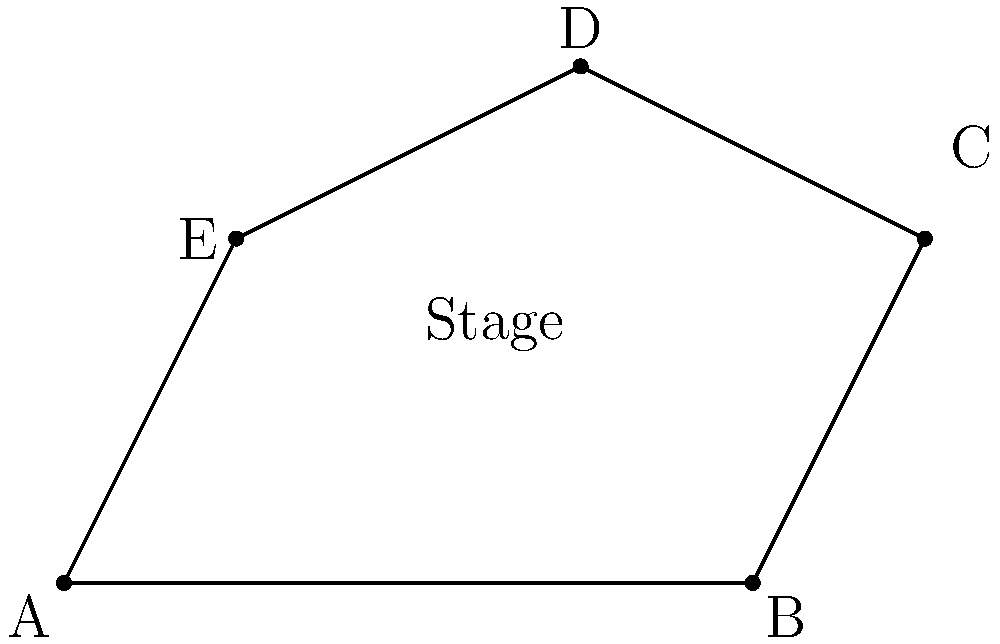Hey there, joke-slinger! You've been asked to perform on this weirdly shaped stage that looks like it was designed by a drunk geometry teacher. The stage's corners are at points A(0,0), B(8,0), C(10,4), D(6,6), and E(2,4). What's the area of this comedic playground? And remember, the bigger the stage, the more room for your ego! Alright, let's break this down like we're dissecting a particularly unfunny joke:

1) We can split this irregular shape into three triangles: ABC, ACD, and ADE.

2) For each triangle, we'll use the formula: 
   Area = $\frac{1}{2}|x_1(y_2 - y_3) + x_2(y_3 - y_1) + x_3(y_1 - y_2)|$

3) Triangle ABC:
   $A_{ABC} = \frac{1}{2}|0(0 - 4) + 8(4 - 0) + 10(0 - 0)| = 16$

4) Triangle ACD:
   $A_{ACD} = \frac{1}{2}|0(6 - 0) + 10(0 - 6) + 6(0 - 0)| = 18$

5) Triangle ADE:
   $A_{ADE} = \frac{1}{2}|0(4 - 6) + 2(6 - 0) + 6(0 - 4)| = 10$

6) Total area = $A_{ABC} + A_{ACD} + A_{ADE} = 16 + 18 + 10 = 44$

So, your stage is 44 square units. That's a lot of space to trip over your punchlines!
Answer: 44 square units 